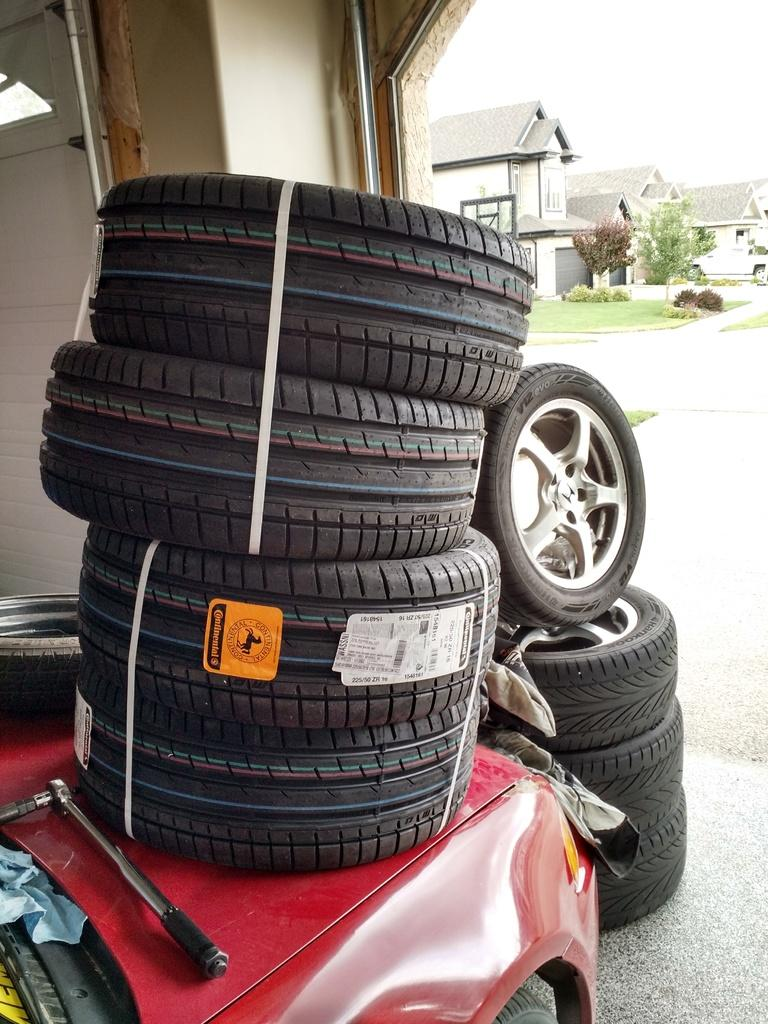What is located on the ground in the image? There is a vehicle on the ground in the image. What type of wheels does the vehicle have? The vehicle has tyres. What can be seen in the distance behind the vehicle? There are houses, trees, and the sky visible in the background of the image. What type of steel is used to construct the zinc building in the image? There is no zinc building present in the image, and therefore no steel construction can be observed. 